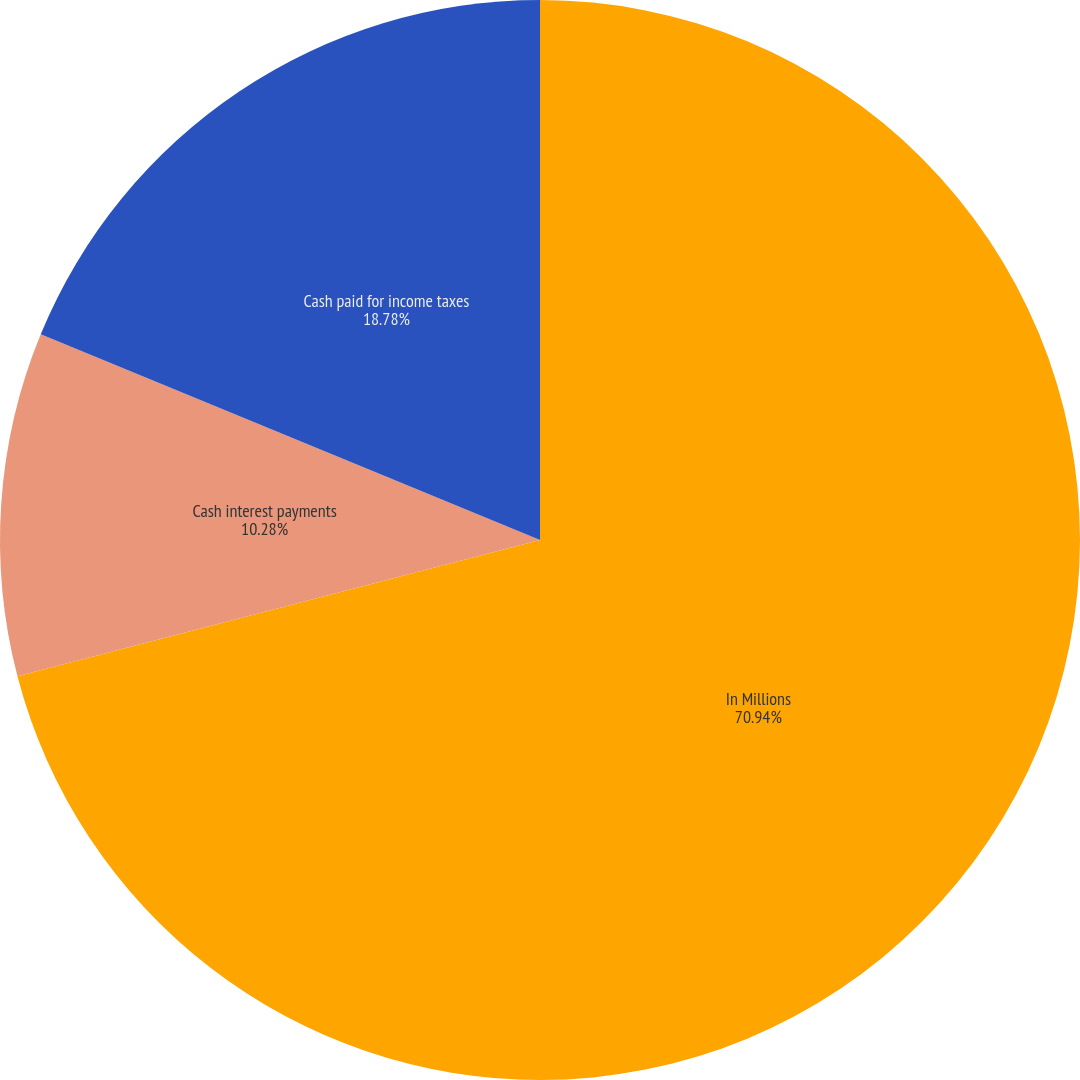<chart> <loc_0><loc_0><loc_500><loc_500><pie_chart><fcel>In Millions<fcel>Cash interest payments<fcel>Cash paid for income taxes<nl><fcel>70.94%<fcel>10.28%<fcel>18.78%<nl></chart> 